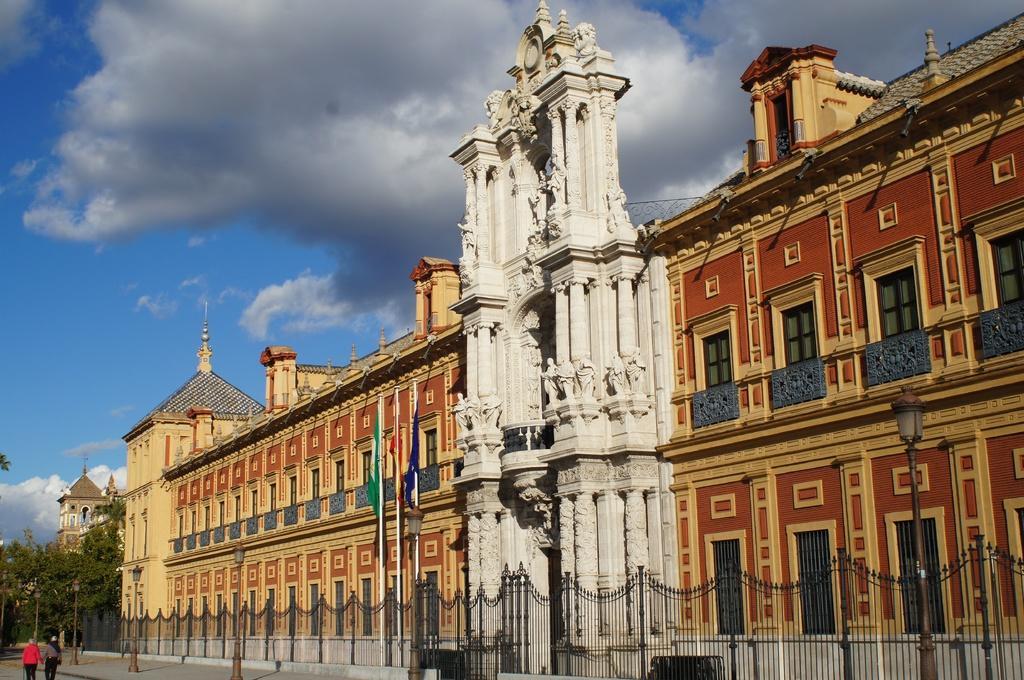Please provide a concise description of this image. In this image I can see two persons are walking on the road, fence, light poles, flags, buildings and windows. In the background I can see trees and the sky. This image is taken may be during a day. 